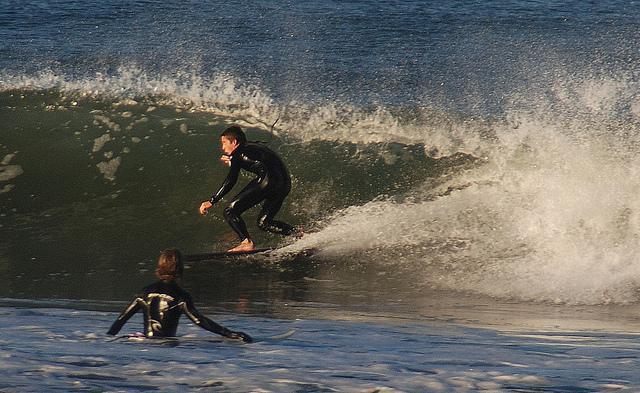How many people can you see?
Give a very brief answer. 2. How many people are standing to the left of the open train door?
Give a very brief answer. 0. 